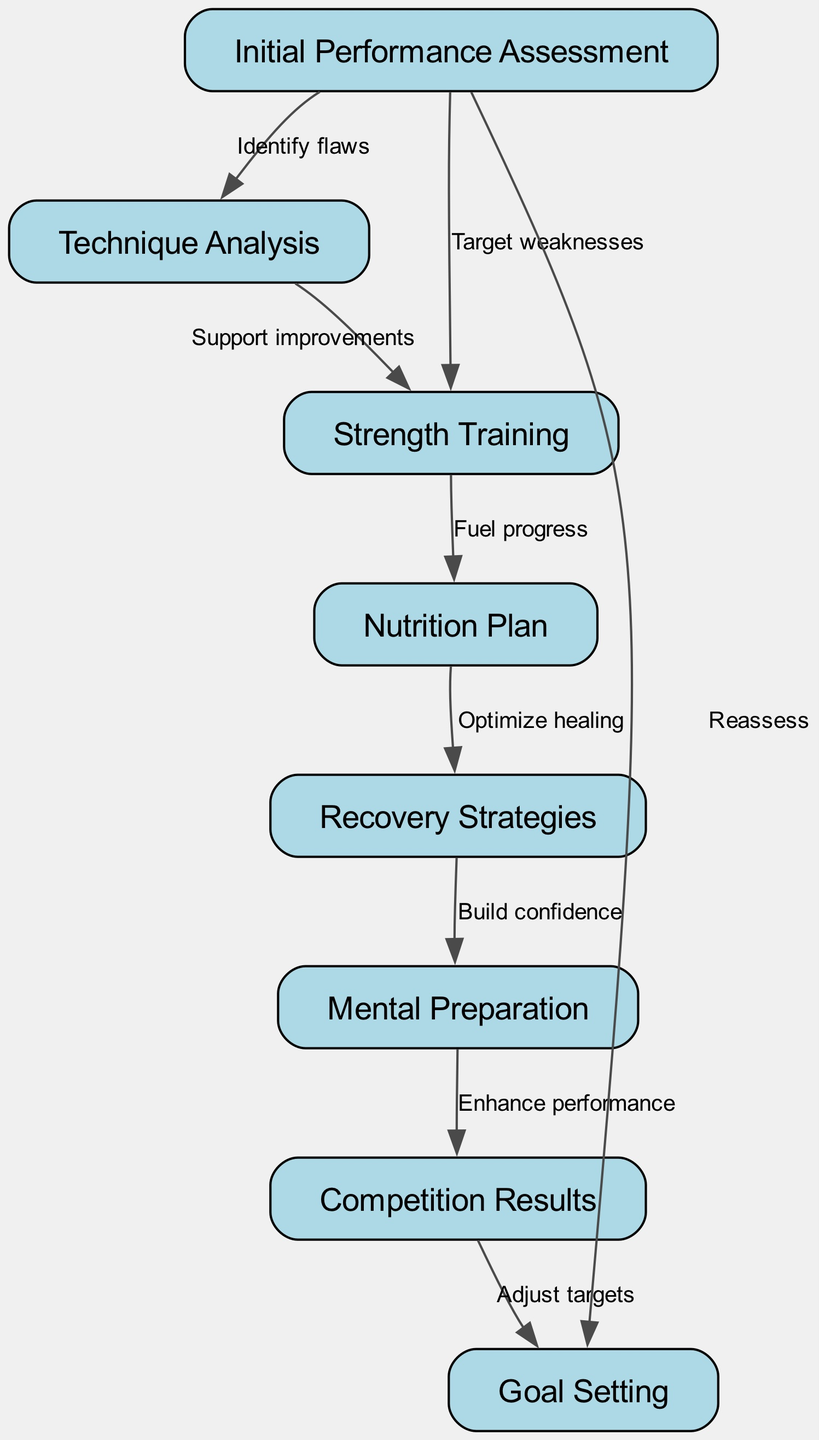What is the first step in the performance improvement pathway? The diagram starts with the node labeled "Initial Performance Assessment," which marks the beginning of the performance improvement process.
Answer: Initial Performance Assessment How many nodes are in the diagram? By counting the unique entities in the diagram, we find there are eight nodes listed that represent different aspects of athlete performance improvement.
Answer: 8 What is the relationship between "Strength Training" and "Nutrition Plan"? The edge connects "Strength Training" to "Nutrition Plan," labeled as "Fuel progress," indicating that adequate nutrition is necessary to support training effectiveness.
Answer: Fuel progress Which node leads to "Goal Setting"? The edge from "Competition Results" points to "Goal Setting," indicating that results from competitions inform and adjust the athlete's targets moving forward.
Answer: Competition Results What does "Recovery Strategies" support according to the diagram? The edge from "Recovery Strategies" to "Mental Preparation" suggests that implementing effective recovery practices helps in reinforcing an athlete's confidence and mental readiness.
Answer: Mental Preparation How does "Technique Analysis" impact "Strength Training"? The diagram shows an edge from "Technique Analysis" to "Strength Training," labeled "Support improvements," which implies that analyzing technique helps identify areas where strength is needed for further development.
Answer: Support improvements What is the ultimate goal after "Goal Setting"? "Goal Setting" leads back to "Initial Performance Assessment," reflecting a continuous improvement cycle where goals set lead to further evaluation and adjustments in performance.
Answer: Initial Performance Assessment Which node can lead to "Recovery Strategies"? "Nutrition Plan" points towards "Recovery Strategies," indicating that a well-planned diet can optimize an athlete's recovery process after training and competition.
Answer: Nutrition Plan What aspect does "Technique Analysis" relate to first in the flow? "Technique Analysis" is directly connected to "Initial Performance Assessment," indicating that evaluation leads to a detailed analysis of the athlete's technique as the first adjustment step.
Answer: Initial Performance Assessment What can be adjusted based on "Competition Results"? The edge from "Competition Results" to "Goal Setting" suggests that athletes can modify their performance targets based on the outcomes of their competitions.
Answer: Adjust targets 